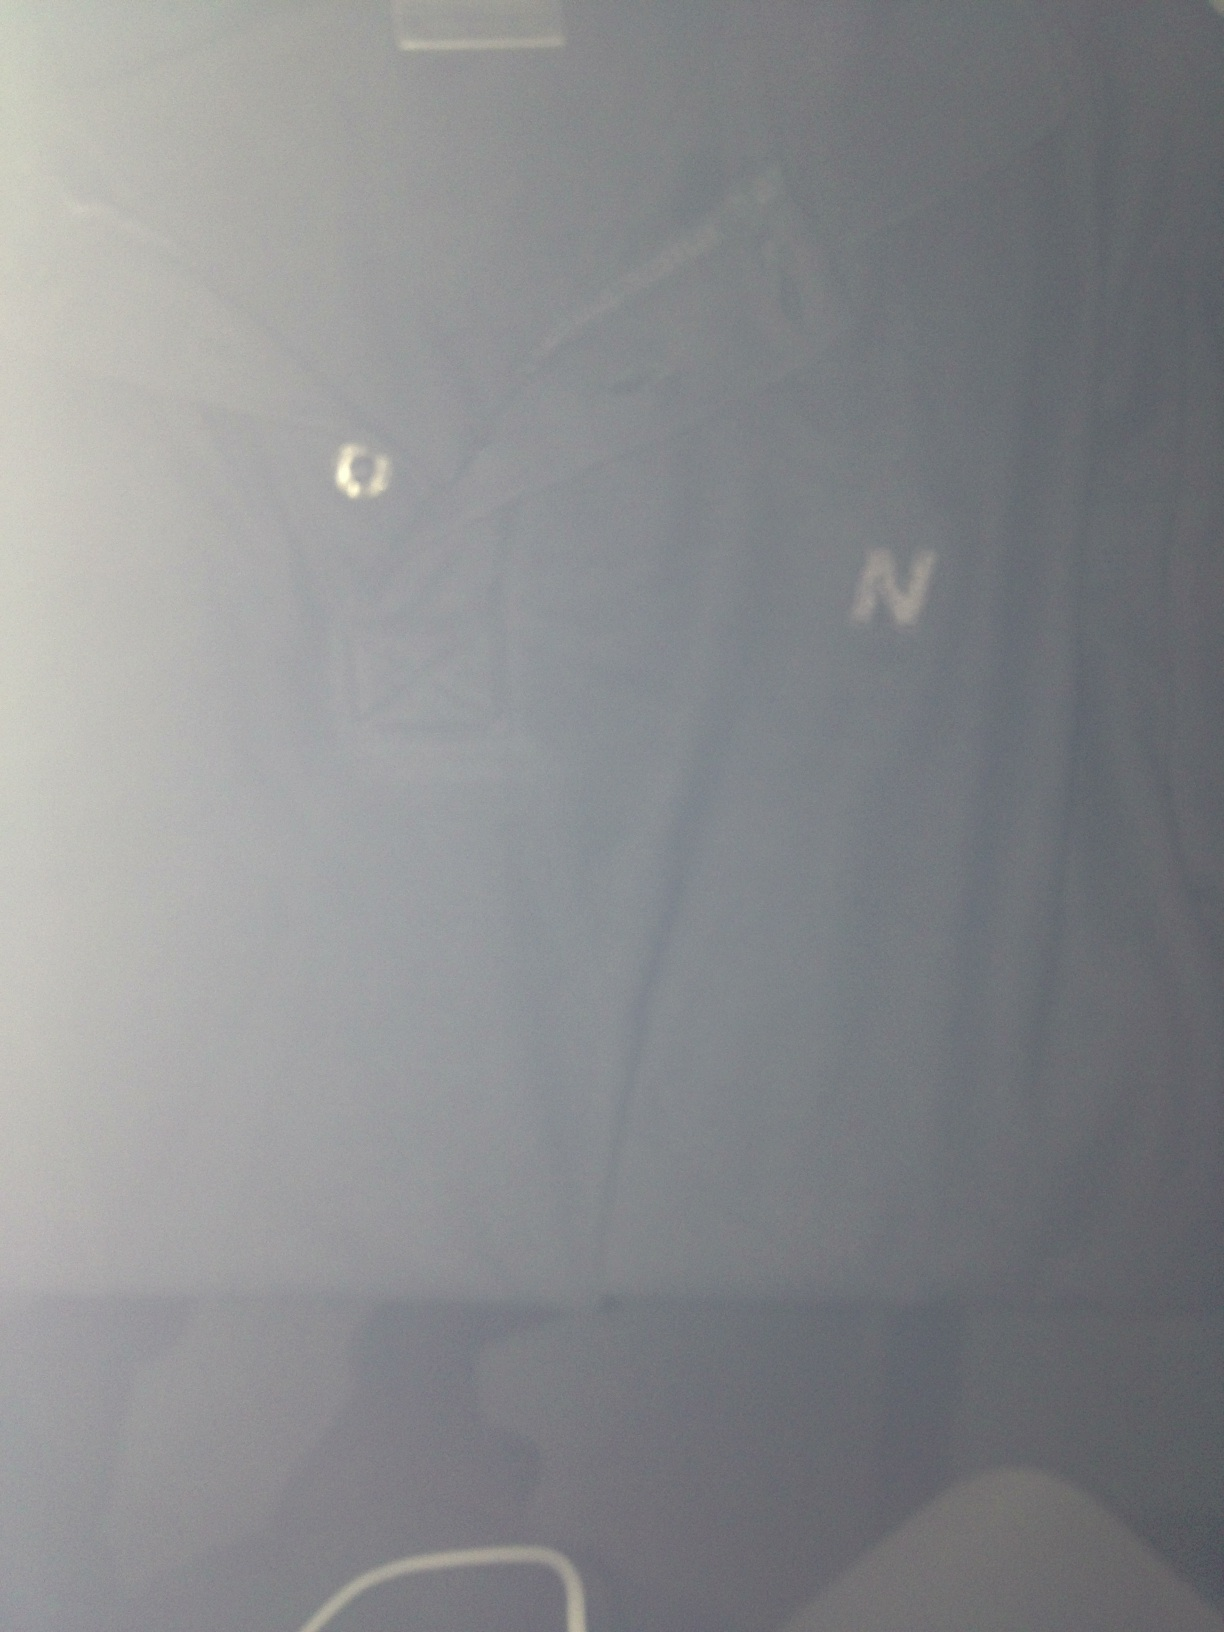Can you describe the details and any notable features on the tee shirt? The tee shirt is predominantly dark blue in color. It features a small emblem or logo, possibly an 'N', located on the left chest area. The shirt also has a collar with a buttoned placket, giving it a slightly more formal look compared to a standard tee shirt. What kind of material do you think this tee shirt is made of? From the image, it seems like the tee shirt could be made of a soft and durable fabric, such as cotton or a cotton blend. These materials are commonly used for casual wear because of their comfort and breathability. What occasion would this tee shirt be suitable for? This dark blue tee shirt with a collar and buttoned placket could be suitable for a variety of casual and semi-casual occasions. It could be worn for a day out, casual Fridays at work, or even a casual dinner. 